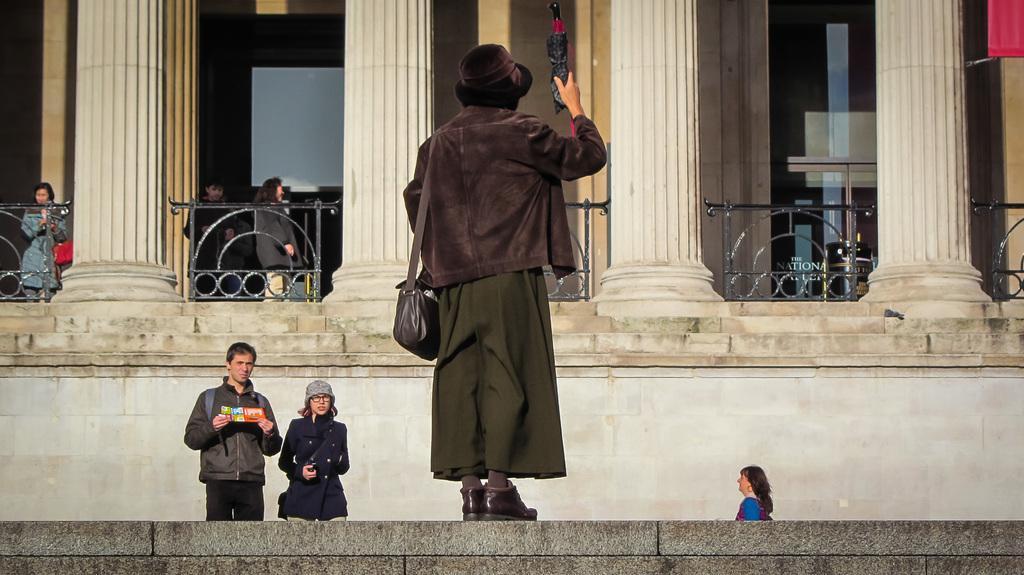Could you give a brief overview of what you see in this image? In the center of the image, we can see a person wearing a bag, coat and a hat and holding an umbrella and standing on the wall. In the background, there are some other people and are wearing coats and one of them is holding an object and we can see railings, pillars and there is a wall. 